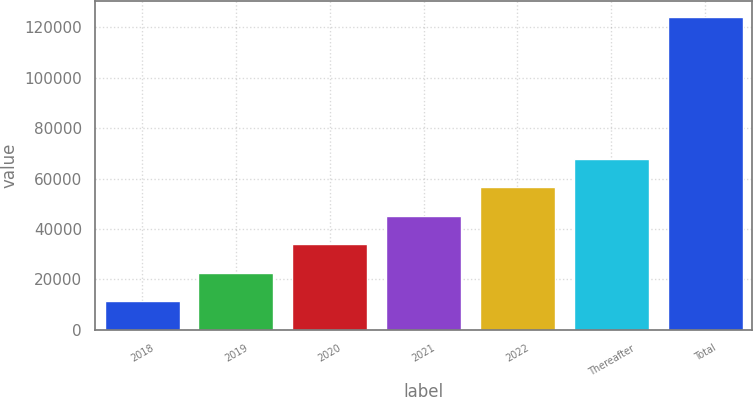Convert chart. <chart><loc_0><loc_0><loc_500><loc_500><bar_chart><fcel>2018<fcel>2019<fcel>2020<fcel>2021<fcel>2022<fcel>Thereafter<fcel>Total<nl><fcel>11500<fcel>22763<fcel>34026<fcel>45289<fcel>56552<fcel>67815<fcel>124130<nl></chart> 